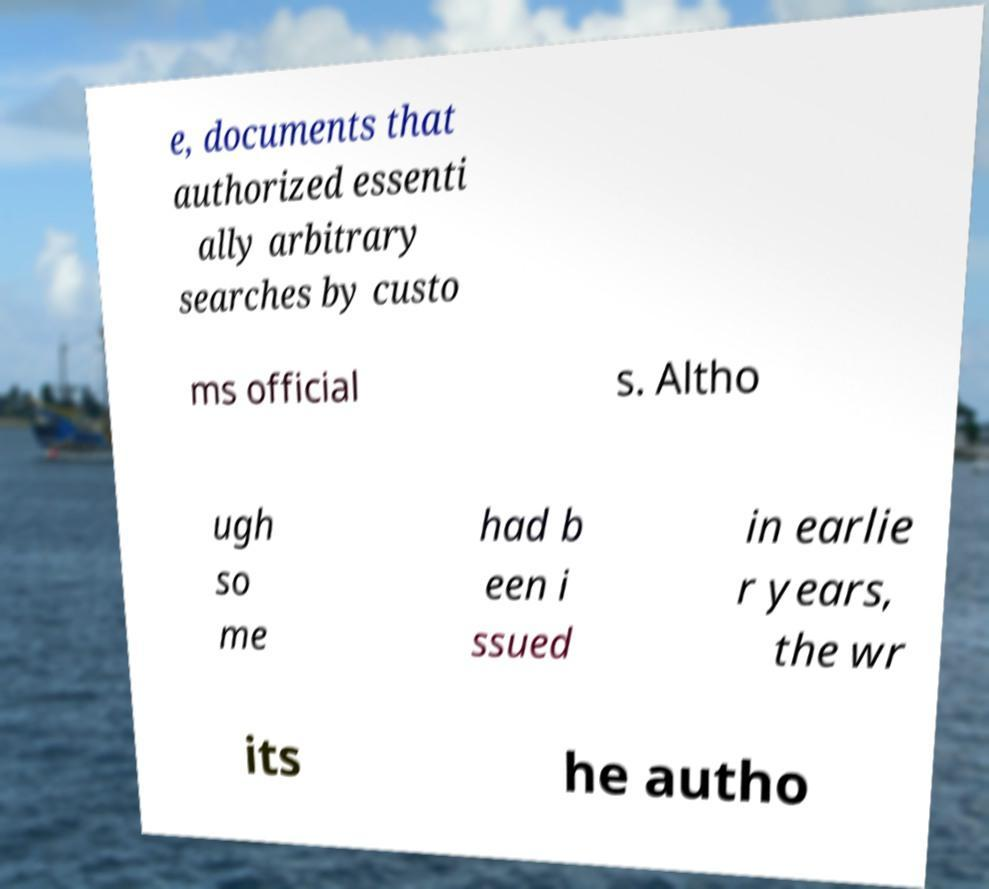Can you read and provide the text displayed in the image?This photo seems to have some interesting text. Can you extract and type it out for me? e, documents that authorized essenti ally arbitrary searches by custo ms official s. Altho ugh so me had b een i ssued in earlie r years, the wr its he autho 